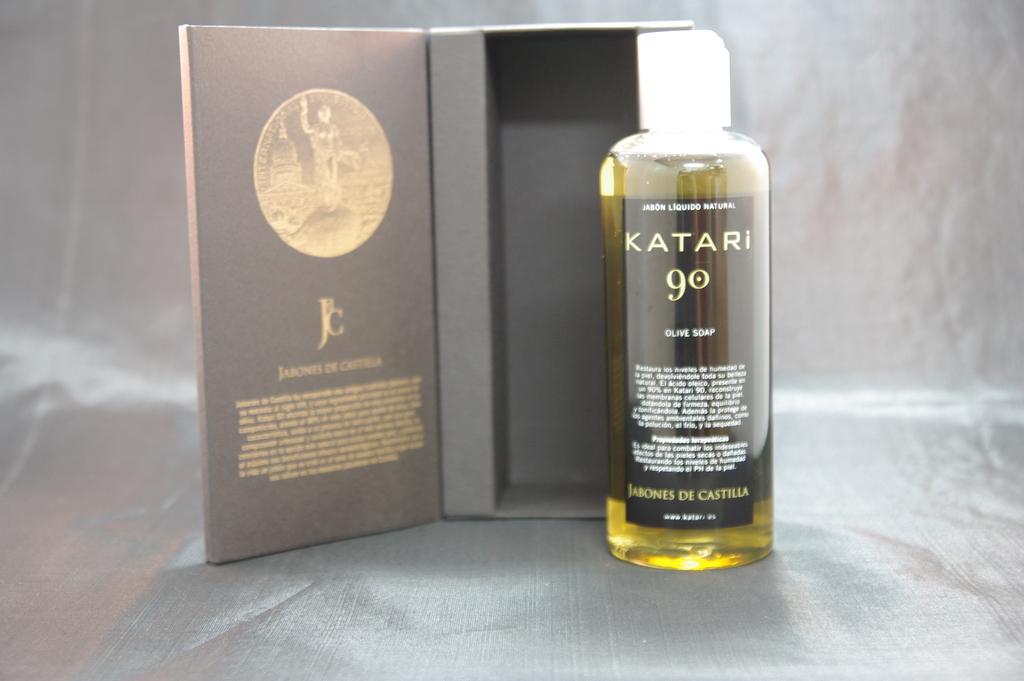What´s the number on the bottle?
Keep it short and to the point. 90. 